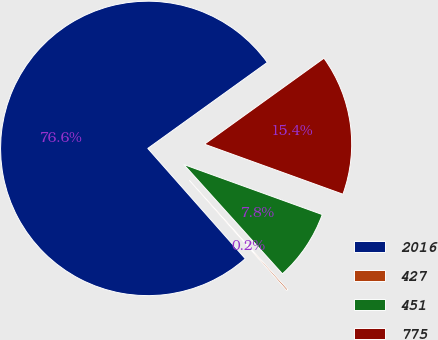Convert chart to OTSL. <chart><loc_0><loc_0><loc_500><loc_500><pie_chart><fcel>2016<fcel>427<fcel>451<fcel>775<nl><fcel>76.6%<fcel>0.16%<fcel>7.8%<fcel>15.45%<nl></chart> 